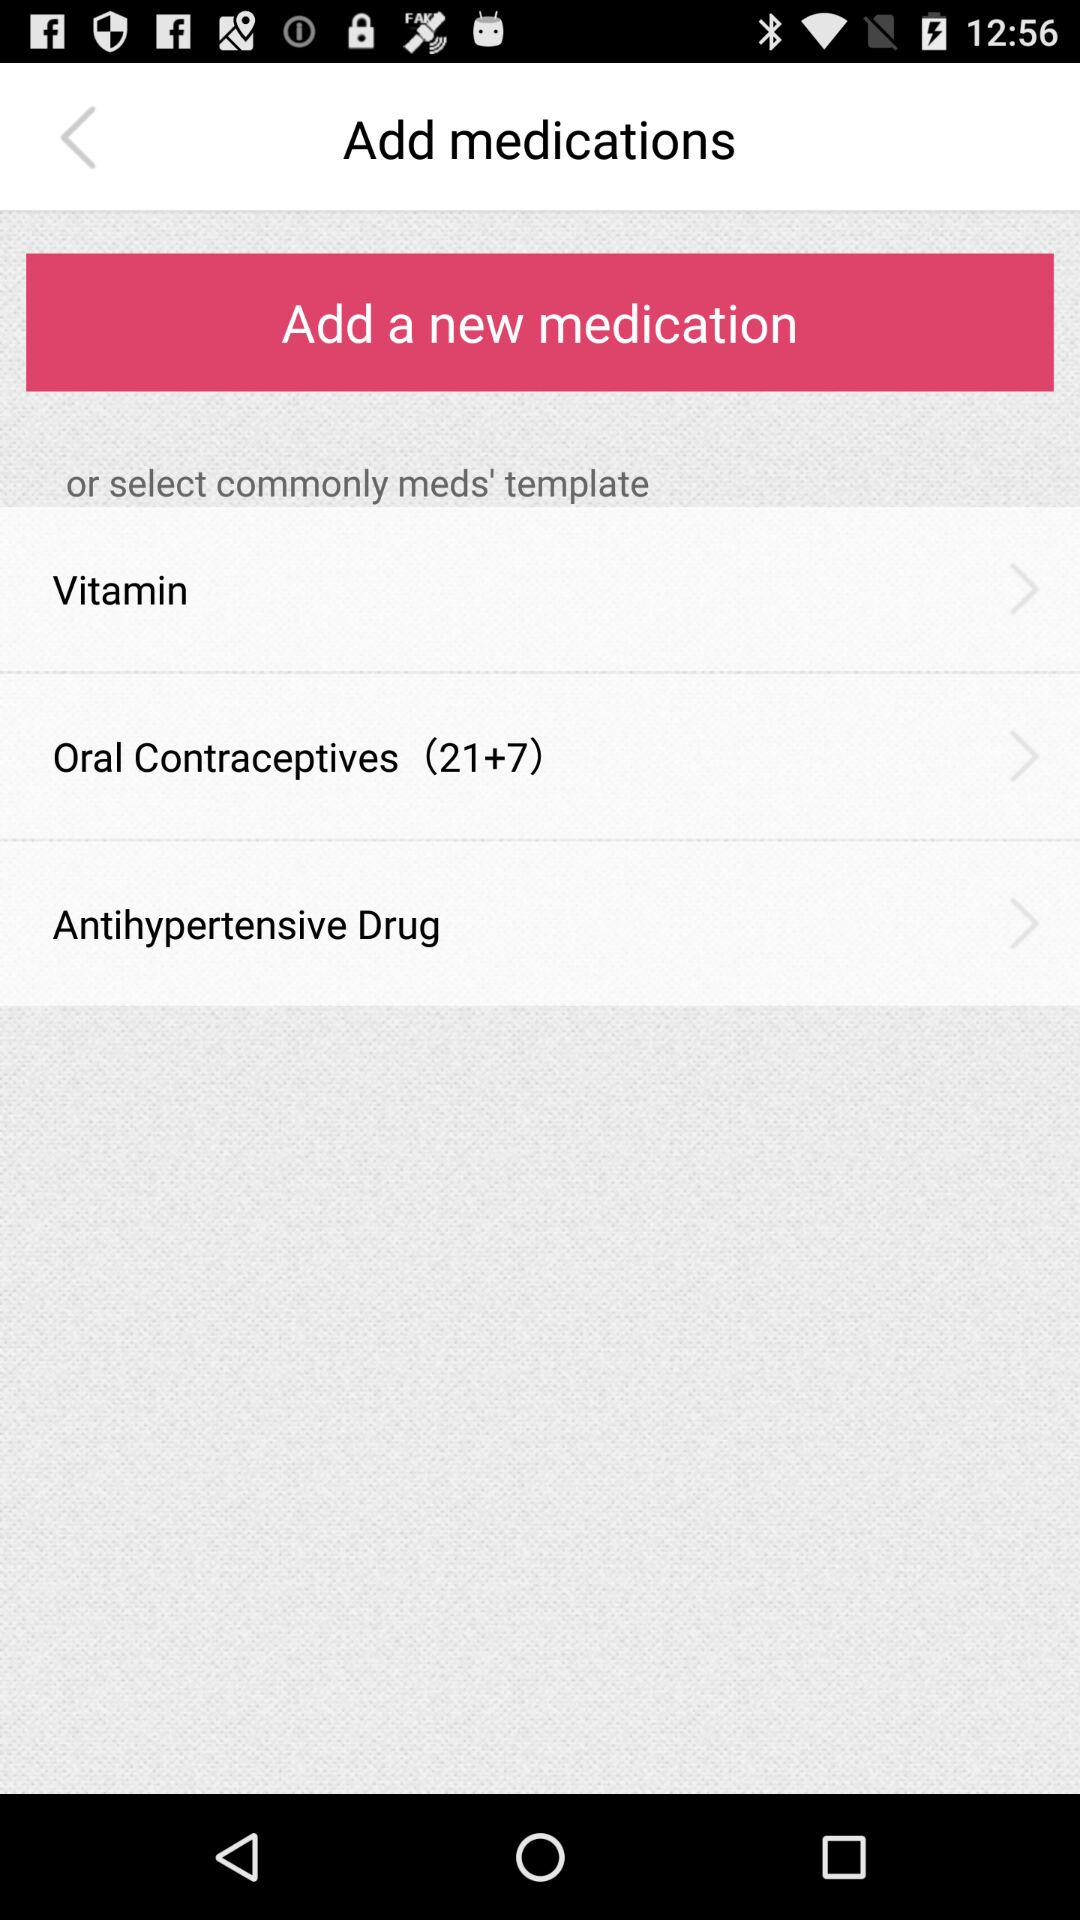What are the available options? The available options are "Vitamin", "Oral Contraceptives (21+7)" and "Antihypertensive Drug". 